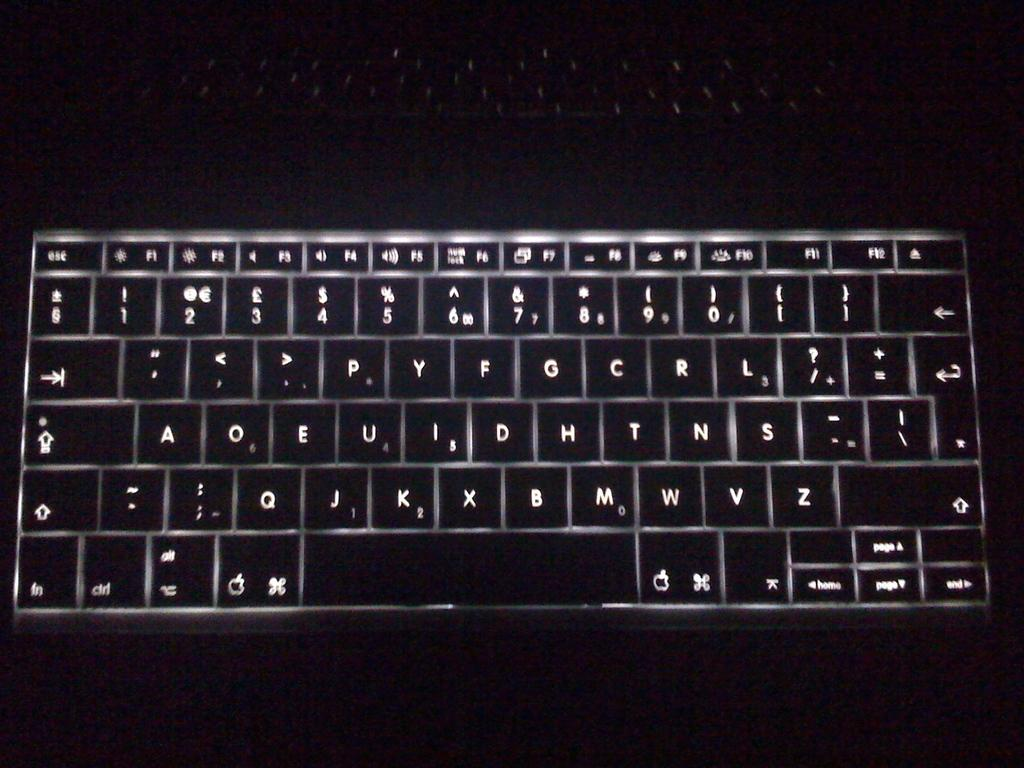<image>
Share a concise interpretation of the image provided. the keyboard of a laptop is lit up and you can read the page up key easily 